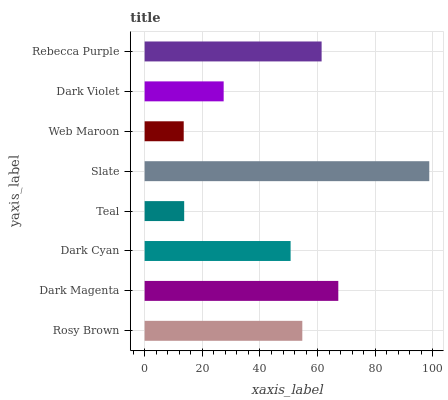Is Web Maroon the minimum?
Answer yes or no. Yes. Is Slate the maximum?
Answer yes or no. Yes. Is Dark Magenta the minimum?
Answer yes or no. No. Is Dark Magenta the maximum?
Answer yes or no. No. Is Dark Magenta greater than Rosy Brown?
Answer yes or no. Yes. Is Rosy Brown less than Dark Magenta?
Answer yes or no. Yes. Is Rosy Brown greater than Dark Magenta?
Answer yes or no. No. Is Dark Magenta less than Rosy Brown?
Answer yes or no. No. Is Rosy Brown the high median?
Answer yes or no. Yes. Is Dark Cyan the low median?
Answer yes or no. Yes. Is Rebecca Purple the high median?
Answer yes or no. No. Is Web Maroon the low median?
Answer yes or no. No. 